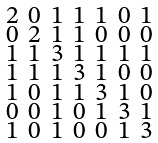<formula> <loc_0><loc_0><loc_500><loc_500>\begin{smallmatrix} 2 & 0 & 1 & 1 & 1 & 0 & 1 \\ 0 & 2 & 1 & 1 & 0 & 0 & 0 \\ 1 & 1 & 3 & 1 & 1 & 1 & 1 \\ 1 & 1 & 1 & 3 & 1 & 0 & 0 \\ 1 & 0 & 1 & 1 & 3 & 1 & 0 \\ 0 & 0 & 1 & 0 & 1 & 3 & 1 \\ 1 & 0 & 1 & 0 & 0 & 1 & 3 \end{smallmatrix}</formula> 